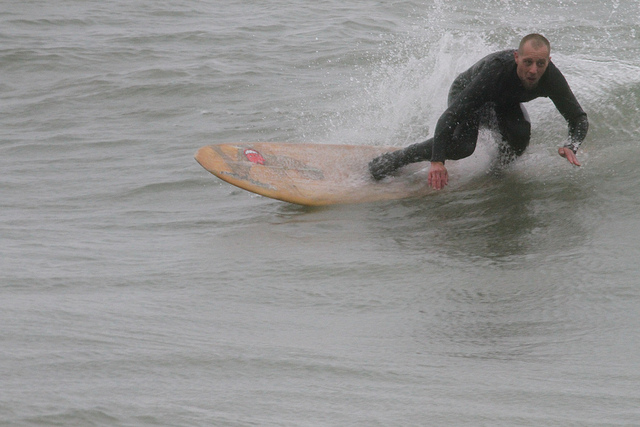<image>Whose mouth is open? I am not sure whose mouth is open. It could be either the man or the surfer. Whose mouth is open? I don't know whose mouth is open. It can be either the man's or the surfer's. 